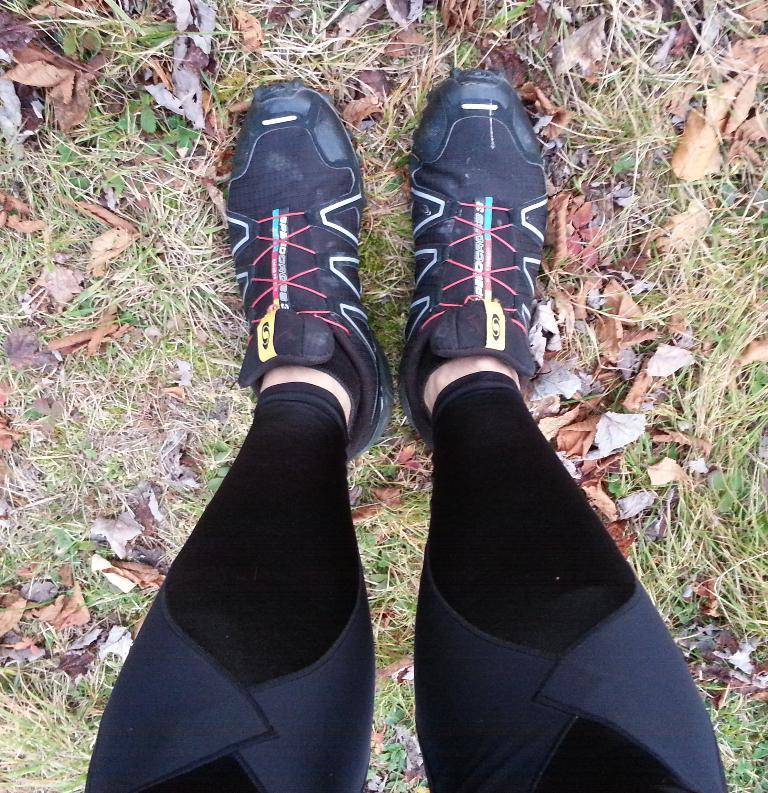What part of a person can be seen in the image? There is a person's legs visible in the image. What type of footwear is the person wearing? The person is wearing shoes. What type of terrain is visible in the image? There is grass in the image. What additional elements can be seen on the ground? Dried leaves are present in the image. What type of ship can be seen in the middle of the image? There is no ship present in the image; it only features a person's legs, grass, and dried leaves. What advice might the person's mother give them in the image? There is no indication of the person's mother or any advice in the image. 